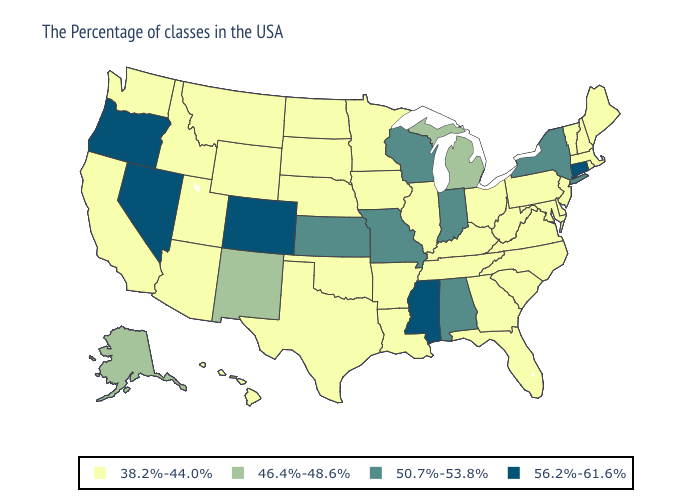What is the lowest value in the USA?
Write a very short answer. 38.2%-44.0%. Which states hav the highest value in the South?
Give a very brief answer. Mississippi. Name the states that have a value in the range 50.7%-53.8%?
Write a very short answer. New York, Indiana, Alabama, Wisconsin, Missouri, Kansas. Which states have the lowest value in the USA?
Keep it brief. Maine, Massachusetts, Rhode Island, New Hampshire, Vermont, New Jersey, Delaware, Maryland, Pennsylvania, Virginia, North Carolina, South Carolina, West Virginia, Ohio, Florida, Georgia, Kentucky, Tennessee, Illinois, Louisiana, Arkansas, Minnesota, Iowa, Nebraska, Oklahoma, Texas, South Dakota, North Dakota, Wyoming, Utah, Montana, Arizona, Idaho, California, Washington, Hawaii. Name the states that have a value in the range 56.2%-61.6%?
Be succinct. Connecticut, Mississippi, Colorado, Nevada, Oregon. What is the value of Hawaii?
Answer briefly. 38.2%-44.0%. Which states have the lowest value in the USA?
Be succinct. Maine, Massachusetts, Rhode Island, New Hampshire, Vermont, New Jersey, Delaware, Maryland, Pennsylvania, Virginia, North Carolina, South Carolina, West Virginia, Ohio, Florida, Georgia, Kentucky, Tennessee, Illinois, Louisiana, Arkansas, Minnesota, Iowa, Nebraska, Oklahoma, Texas, South Dakota, North Dakota, Wyoming, Utah, Montana, Arizona, Idaho, California, Washington, Hawaii. What is the value of Oregon?
Quick response, please. 56.2%-61.6%. Among the states that border Indiana , which have the highest value?
Concise answer only. Michigan. Name the states that have a value in the range 56.2%-61.6%?
Quick response, please. Connecticut, Mississippi, Colorado, Nevada, Oregon. What is the value of Texas?
Keep it brief. 38.2%-44.0%. Does New York have the lowest value in the Northeast?
Be succinct. No. Which states hav the highest value in the MidWest?
Answer briefly. Indiana, Wisconsin, Missouri, Kansas. Name the states that have a value in the range 56.2%-61.6%?
Be succinct. Connecticut, Mississippi, Colorado, Nevada, Oregon. What is the value of Missouri?
Concise answer only. 50.7%-53.8%. 